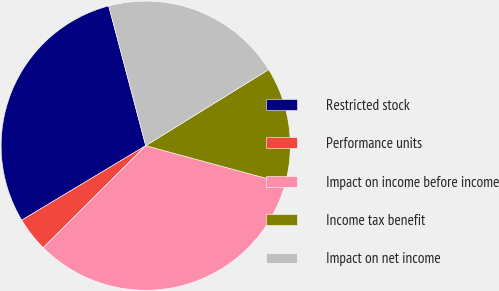Convert chart to OTSL. <chart><loc_0><loc_0><loc_500><loc_500><pie_chart><fcel>Restricted stock<fcel>Performance units<fcel>Impact on income before income<fcel>Income tax benefit<fcel>Impact on net income<nl><fcel>29.49%<fcel>3.85%<fcel>33.33%<fcel>13.03%<fcel>20.3%<nl></chart> 